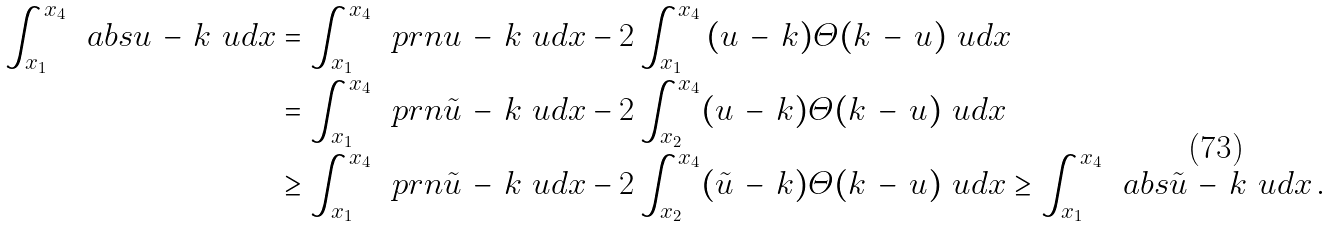Convert formula to latex. <formula><loc_0><loc_0><loc_500><loc_500>\int _ { x _ { 1 } } ^ { x _ { 4 } } \, \ a b s { u \, - \, k } \ u d { x } & = \int _ { x _ { 1 } } ^ { x _ { 4 } } \, \ p r n { u \, - \, k } \ u d { x } - 2 \int _ { x _ { 1 } } ^ { x _ { 4 } } \, ( u \, - \, k ) \varTheta ( k \, - \, u ) \ u d { x } \\ & = \int _ { x _ { 1 } } ^ { x _ { 4 } } \, \ p r n { \tilde { u } \, - \, k } \ u d { x } - 2 \int _ { x _ { 2 } } ^ { x _ { 4 } } ( u \, - \, k ) \varTheta ( k \, - \, u ) \ u d { x } \\ & \geq \int _ { x _ { 1 } } ^ { x _ { 4 } } \, \ p r n { \tilde { u } \, - \, k } \ u d { x } - 2 \int _ { x _ { 2 } } ^ { x _ { 4 } } ( \tilde { u } \, - \, k ) \varTheta ( k \, - \, u ) \ u d { x } \geq \int _ { x _ { 1 } } ^ { x _ { 4 } } \, \ a b s { \tilde { u } \, - \, k } \ u d { x } \, .</formula> 